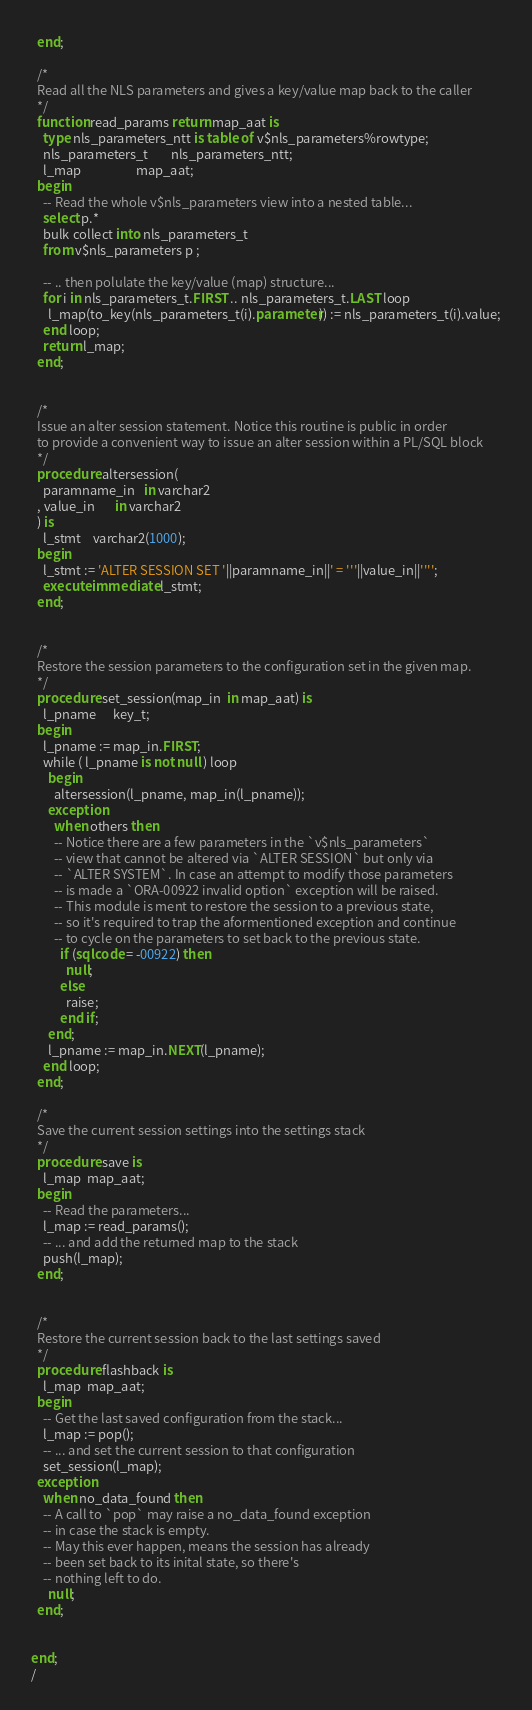Convert code to text. <code><loc_0><loc_0><loc_500><loc_500><_SQL_>  end;

  /* 
  Read all the NLS parameters and gives a key/value map back to the caller 
  */
  function read_params return map_aat is
    type nls_parameters_ntt is table of v$nls_parameters%rowtype;
    nls_parameters_t        nls_parameters_ntt;
    l_map                   map_aat;
  begin
    -- Read the whole v$nls_parameters view into a nested table...
    select p.*
    bulk collect into nls_parameters_t
    from v$nls_parameters p ;
    
    -- .. then polulate the key/value (map) structure...
    for i in nls_parameters_t.FIRST .. nls_parameters_t.LAST loop
      l_map(to_key(nls_parameters_t(i).parameter)) := nls_parameters_t(i).value;
    end loop;
    return l_map;
  end;


  /* 
  Issue an alter session statement. Notice this routine is public in order 
  to provide a convenient way to issue an alter session within a PL/SQL block
  */
  procedure altersession(
    paramname_in   in varchar2
  , value_in       in varchar2
  ) is
    l_stmt    varchar2(1000);
  begin
    l_stmt := 'ALTER SESSION SET '||paramname_in||' = '''||value_in||'''';
    execute immediate l_stmt;
  end;


  /*
  Restore the session parameters to the configuration set in the given map.
  */
  procedure set_session(map_in  in map_aat) is
    l_pname      key_t;
  begin
    l_pname := map_in.FIRST;
    while ( l_pname is not null ) loop
      begin
        altersession(l_pname, map_in(l_pname));
      exception
        when others then
        -- Notice there are a few parameters in the `v$nls_parameters`
        -- view that cannot be altered via `ALTER SESSION` but only via
        -- `ALTER SYSTEM`. In case an attempt to modify those parameters
        -- is made a `ORA-00922 invalid option` exception will be raised.
        -- This module is ment to restore the session to a previous state,
        -- so it's required to trap the aformentioned exception and continue
        -- to cycle on the parameters to set back to the previous state.
          if (sqlcode = -00922) then
            null;
          else
            raise;
          end if;  
      end;  
      l_pname := map_in.NEXT(l_pname);
    end loop;
  end;
  
  /* 
  Save the current session settings into the settings stack 
  */
  procedure save is
    l_map  map_aat;
  begin
    -- Read the parameters...
    l_map := read_params();
    -- ... and add the returned map to the stack
    push(l_map);
  end;
  
  
  /* 
  Restore the current session back to the last settings saved 
  */
  procedure flashback is
    l_map  map_aat;
  begin
    -- Get the last saved configuration from the stack...
    l_map := pop();
    -- ... and set the current session to that configuration
    set_session(l_map);
  exception
    when no_data_found then
    -- A call to `pop` may raise a no_data_found exception
    -- in case the stack is empty.
    -- May this ever happen, means the session has already
    -- been set back to its inital state, so there's
    -- nothing left to do.
      null; 
  end;
  

end;
/</code> 